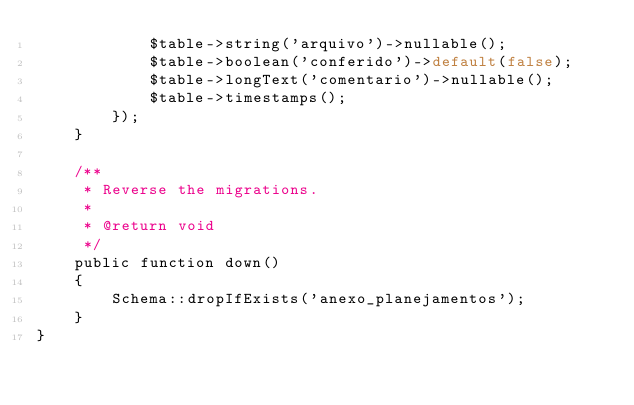Convert code to text. <code><loc_0><loc_0><loc_500><loc_500><_PHP_>            $table->string('arquivo')->nullable();
            $table->boolean('conferido')->default(false);
            $table->longText('comentario')->nullable();
            $table->timestamps();
        });
    }

    /**
     * Reverse the migrations.
     *
     * @return void
     */
    public function down()
    {
        Schema::dropIfExists('anexo_planejamentos');
    }
}
</code> 